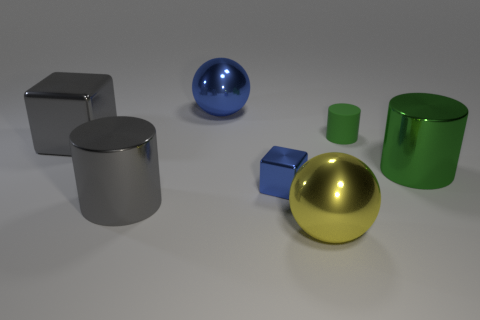Is the small blue cube made of the same material as the small green thing?
Offer a very short reply. No. The sphere that is in front of the object that is on the right side of the rubber cylinder is made of what material?
Provide a short and direct response. Metal. Are there any big gray shiny blocks on the right side of the small green object?
Your answer should be very brief. No. Is the number of blue balls that are to the left of the green metallic thing greater than the number of large gray matte cubes?
Ensure brevity in your answer.  Yes. Is there a big metallic object of the same color as the large block?
Your answer should be compact. Yes. What is the color of the other metal sphere that is the same size as the yellow ball?
Your answer should be compact. Blue. Is there a big gray metallic object behind the big cylinder that is in front of the tiny blue block?
Offer a very short reply. Yes. What is the material of the object that is behind the tiny matte cylinder?
Give a very brief answer. Metal. Does the big cylinder that is on the right side of the yellow metallic ball have the same material as the tiny object behind the small cube?
Provide a succinct answer. No. Are there the same number of big yellow objects to the right of the tiny green rubber cylinder and big shiny objects behind the gray shiny cylinder?
Offer a terse response. No. 